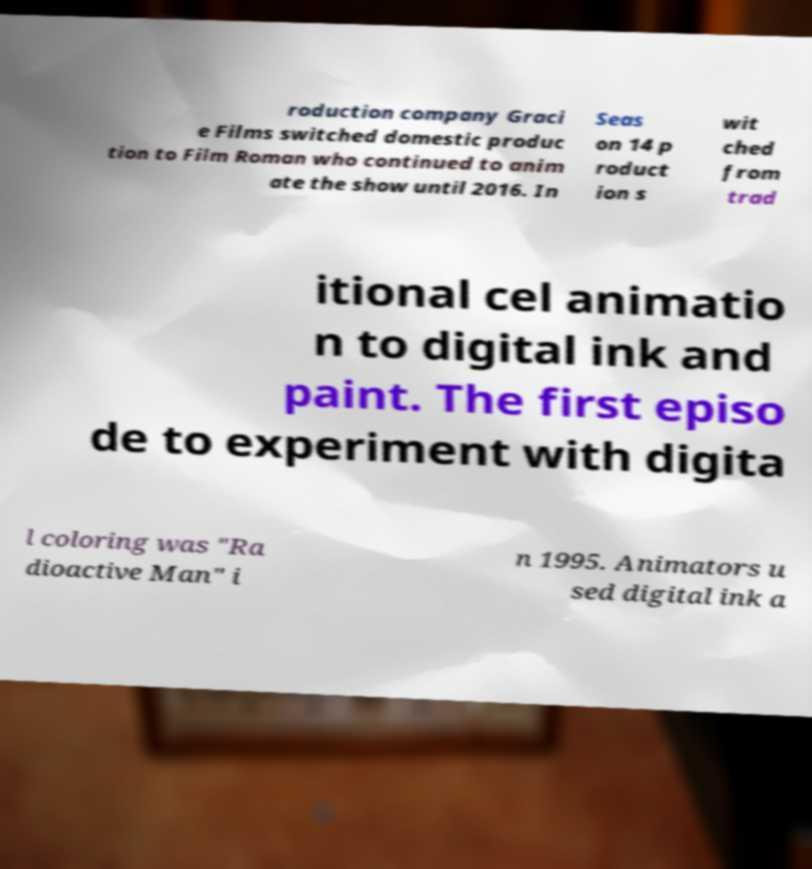Can you read and provide the text displayed in the image?This photo seems to have some interesting text. Can you extract and type it out for me? roduction company Graci e Films switched domestic produc tion to Film Roman who continued to anim ate the show until 2016. In Seas on 14 p roduct ion s wit ched from trad itional cel animatio n to digital ink and paint. The first episo de to experiment with digita l coloring was "Ra dioactive Man" i n 1995. Animators u sed digital ink a 